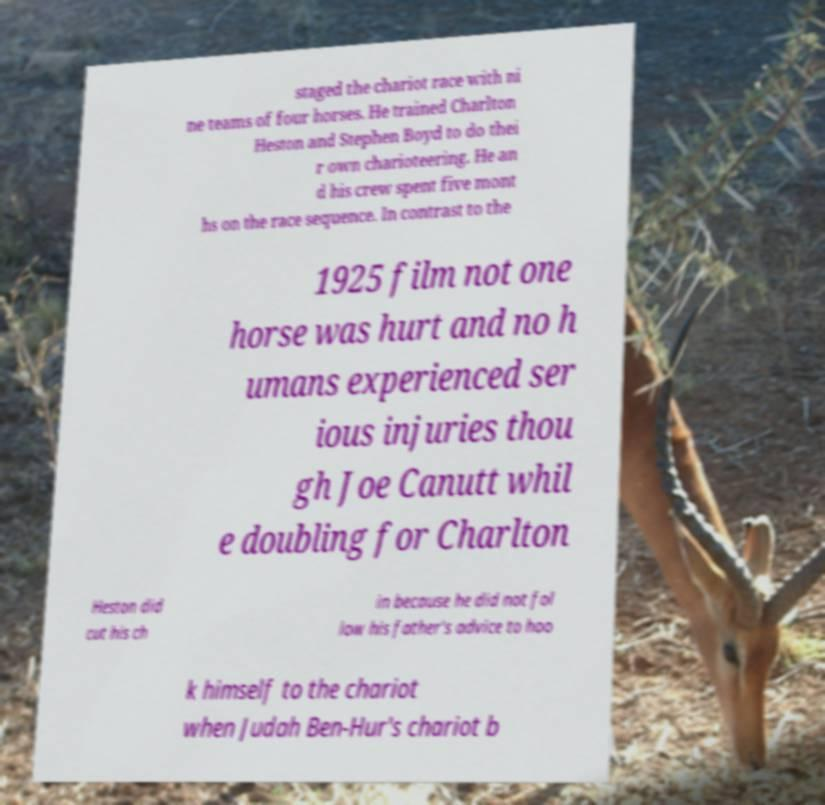What messages or text are displayed in this image? I need them in a readable, typed format. staged the chariot race with ni ne teams of four horses. He trained Charlton Heston and Stephen Boyd to do thei r own charioteering. He an d his crew spent five mont hs on the race sequence. In contrast to the 1925 film not one horse was hurt and no h umans experienced ser ious injuries thou gh Joe Canutt whil e doubling for Charlton Heston did cut his ch in because he did not fol low his father's advice to hoo k himself to the chariot when Judah Ben-Hur's chariot b 